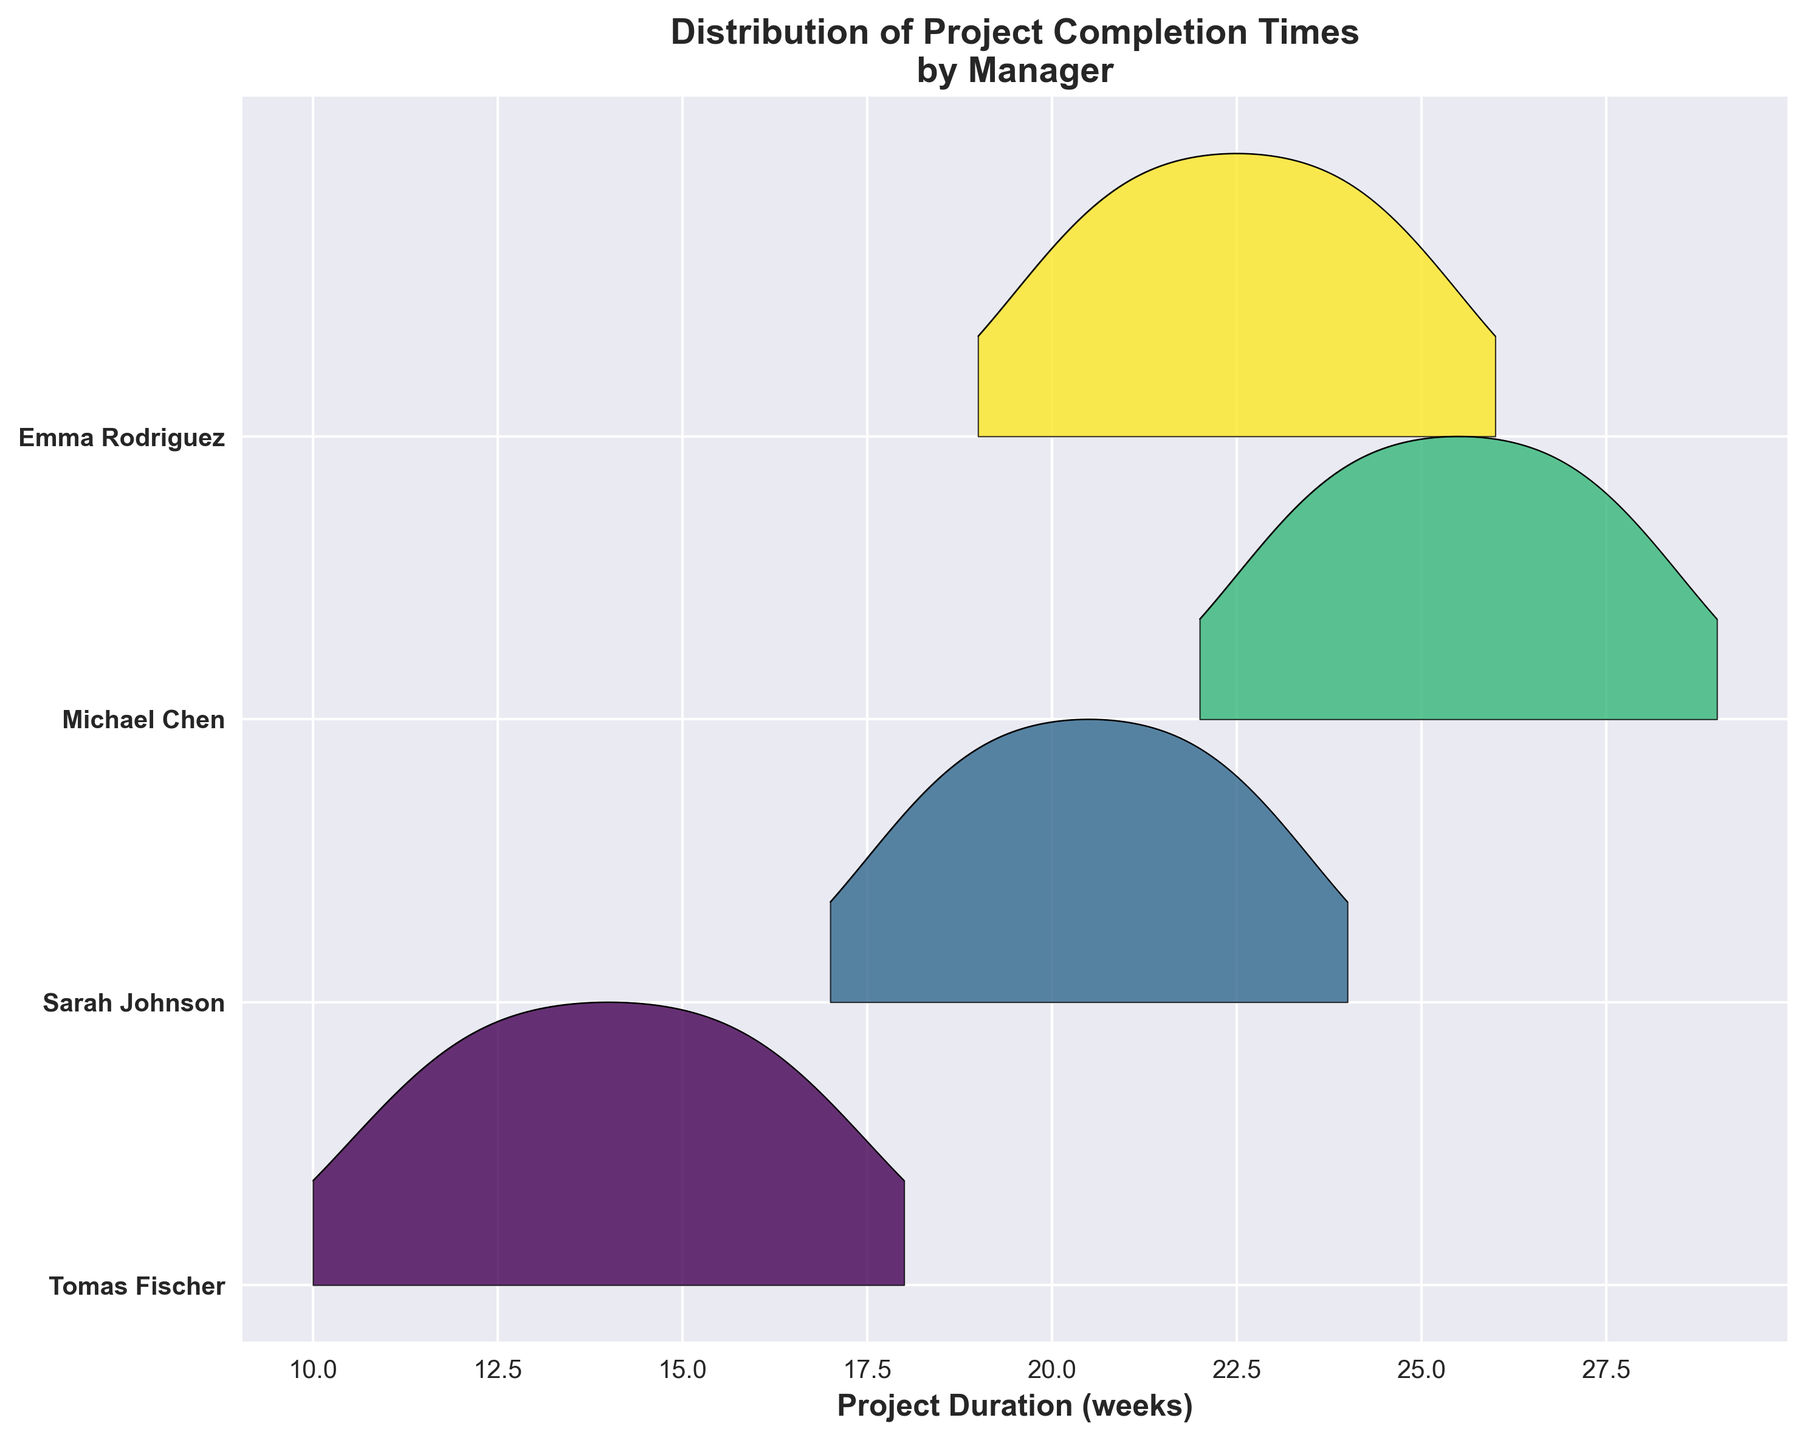What is the title of the plot? The title of the plot is prominently displayed at the top of the figure and usually provides a brief summary of what the plot represents.
Answer: Distribution of Project Completion Times by Manager Which manager has the shortest project completion time? Tomas Fischer's curve begins at the lowest value on the x-axis, indicating the shortest project duration.
Answer: Tomas Fischer How many unique managers are represented in the plot? Each ridge in the plot represents a different manager, and by counting the ridges or the y-axis labels, we can determine the number of unique managers.
Answer: 4 What is the range of project completion times for Michael Chen? Michael Chen's distribution starts at 23 weeks and ends at 28 weeks, as indicated by the spread of his ridge.
Answer: 23 to 28 weeks Which manager has the most concentrated distribution of project completion times? A concentrated distribution has a narrow ridge. By comparing the width of ridges, Tomas Fischer's distribution appears narrower than others.
Answer: Tomas Fischer Who has the longest duration for project completion on average? The average project completion time is the center of the ridges. By comparing the central tendencies, Michael Chen's ridge is centered around the highest values.
Answer: Michael Chen By how many weeks do the median completion times of Sarah Johnson and Emma Rodriguez differ? The median can be approximated by the peak of each ridge. The difference between the peaks of Sarah Johnson (around 21) and Emma Rodriguez (around 22.5) can be calculated.
Answer: 1.5 weeks Which manager's projects vary the most in completion time? The manager with the widest spread in their ridge has the most variation. Michael Chen's ridge spans the widest range.
Answer: Michael Chen Which managers have overlapping distributions of project completion times? Overlapping distributions can be observed where ridges intersect. Tomas Fischer and Sarah Johnson's ridges overlap around 17-18 weeks.
Answer: Tomas Fischer and Sarah Johnson In descending order, list the managers based on their minimum project completion times. Minimum project completion times are indicated by where each ridge starts on the x-axis. Ordering these values gives Tomas Fischer, Sarah Johnson, Emma Rodriguez, and Michael Chen.
Answer: Tomas Fischer, Sarah Johnson, Emma Rodriguez, Michael Chen 